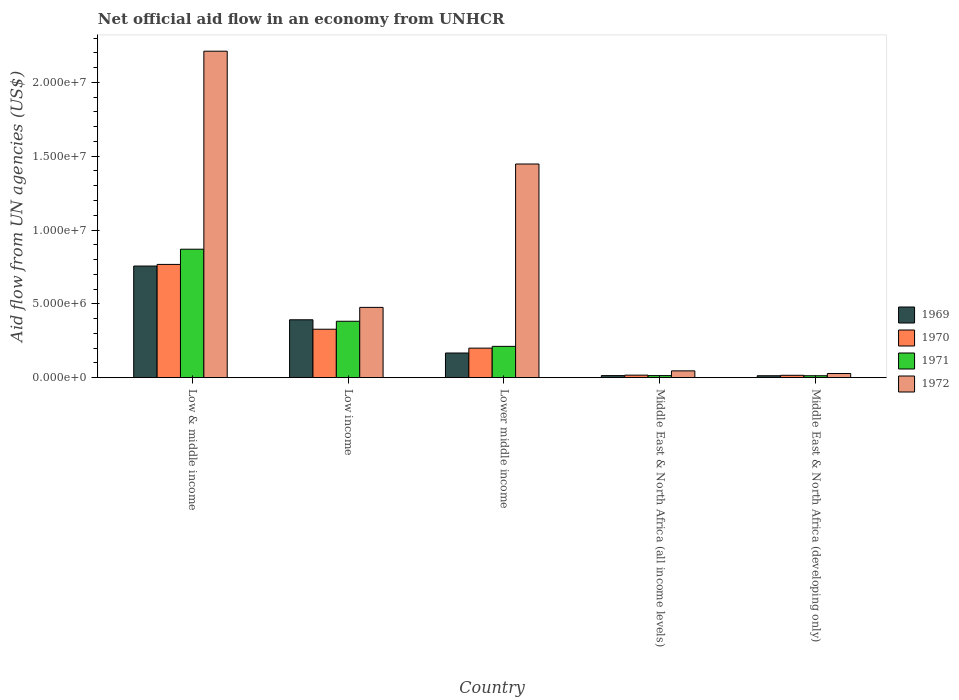How many groups of bars are there?
Provide a succinct answer. 5. What is the label of the 3rd group of bars from the left?
Your answer should be compact. Lower middle income. In how many cases, is the number of bars for a given country not equal to the number of legend labels?
Offer a terse response. 0. What is the net official aid flow in 1969 in Lower middle income?
Your response must be concise. 1.67e+06. Across all countries, what is the maximum net official aid flow in 1970?
Keep it short and to the point. 7.67e+06. Across all countries, what is the minimum net official aid flow in 1970?
Offer a terse response. 1.60e+05. In which country was the net official aid flow in 1969 maximum?
Your response must be concise. Low & middle income. In which country was the net official aid flow in 1971 minimum?
Offer a terse response. Middle East & North Africa (developing only). What is the total net official aid flow in 1969 in the graph?
Your answer should be very brief. 1.34e+07. What is the difference between the net official aid flow in 1971 in Low & middle income and that in Lower middle income?
Your answer should be very brief. 6.58e+06. What is the difference between the net official aid flow in 1972 in Low income and the net official aid flow in 1971 in Low & middle income?
Your answer should be compact. -3.94e+06. What is the average net official aid flow in 1971 per country?
Your response must be concise. 2.98e+06. What is the difference between the net official aid flow of/in 1969 and net official aid flow of/in 1971 in Low & middle income?
Provide a short and direct response. -1.14e+06. In how many countries, is the net official aid flow in 1971 greater than 3000000 US$?
Ensure brevity in your answer.  2. What is the difference between the highest and the second highest net official aid flow in 1971?
Give a very brief answer. 4.88e+06. What is the difference between the highest and the lowest net official aid flow in 1972?
Your answer should be very brief. 2.18e+07. In how many countries, is the net official aid flow in 1972 greater than the average net official aid flow in 1972 taken over all countries?
Keep it short and to the point. 2. How many bars are there?
Offer a terse response. 20. How many countries are there in the graph?
Your response must be concise. 5. Are the values on the major ticks of Y-axis written in scientific E-notation?
Make the answer very short. Yes. Does the graph contain any zero values?
Offer a terse response. No. Where does the legend appear in the graph?
Your response must be concise. Center right. How many legend labels are there?
Provide a succinct answer. 4. How are the legend labels stacked?
Offer a terse response. Vertical. What is the title of the graph?
Your response must be concise. Net official aid flow in an economy from UNHCR. Does "1971" appear as one of the legend labels in the graph?
Make the answer very short. Yes. What is the label or title of the X-axis?
Offer a terse response. Country. What is the label or title of the Y-axis?
Ensure brevity in your answer.  Aid flow from UN agencies (US$). What is the Aid flow from UN agencies (US$) in 1969 in Low & middle income?
Your answer should be very brief. 7.56e+06. What is the Aid flow from UN agencies (US$) of 1970 in Low & middle income?
Ensure brevity in your answer.  7.67e+06. What is the Aid flow from UN agencies (US$) of 1971 in Low & middle income?
Offer a very short reply. 8.70e+06. What is the Aid flow from UN agencies (US$) in 1972 in Low & middle income?
Make the answer very short. 2.21e+07. What is the Aid flow from UN agencies (US$) of 1969 in Low income?
Make the answer very short. 3.92e+06. What is the Aid flow from UN agencies (US$) in 1970 in Low income?
Your answer should be very brief. 3.28e+06. What is the Aid flow from UN agencies (US$) of 1971 in Low income?
Your response must be concise. 3.82e+06. What is the Aid flow from UN agencies (US$) in 1972 in Low income?
Your answer should be very brief. 4.76e+06. What is the Aid flow from UN agencies (US$) of 1969 in Lower middle income?
Offer a terse response. 1.67e+06. What is the Aid flow from UN agencies (US$) of 1971 in Lower middle income?
Your answer should be very brief. 2.12e+06. What is the Aid flow from UN agencies (US$) of 1972 in Lower middle income?
Give a very brief answer. 1.45e+07. What is the Aid flow from UN agencies (US$) of 1969 in Middle East & North Africa (all income levels)?
Your response must be concise. 1.40e+05. What is the Aid flow from UN agencies (US$) in 1969 in Middle East & North Africa (developing only)?
Your answer should be compact. 1.30e+05. What is the Aid flow from UN agencies (US$) in 1970 in Middle East & North Africa (developing only)?
Offer a terse response. 1.60e+05. What is the Aid flow from UN agencies (US$) in 1971 in Middle East & North Africa (developing only)?
Keep it short and to the point. 1.30e+05. Across all countries, what is the maximum Aid flow from UN agencies (US$) in 1969?
Keep it short and to the point. 7.56e+06. Across all countries, what is the maximum Aid flow from UN agencies (US$) in 1970?
Offer a terse response. 7.67e+06. Across all countries, what is the maximum Aid flow from UN agencies (US$) of 1971?
Your answer should be compact. 8.70e+06. Across all countries, what is the maximum Aid flow from UN agencies (US$) in 1972?
Ensure brevity in your answer.  2.21e+07. Across all countries, what is the minimum Aid flow from UN agencies (US$) of 1969?
Your answer should be very brief. 1.30e+05. Across all countries, what is the minimum Aid flow from UN agencies (US$) in 1971?
Your answer should be very brief. 1.30e+05. Across all countries, what is the minimum Aid flow from UN agencies (US$) of 1972?
Make the answer very short. 2.80e+05. What is the total Aid flow from UN agencies (US$) in 1969 in the graph?
Provide a short and direct response. 1.34e+07. What is the total Aid flow from UN agencies (US$) in 1970 in the graph?
Your answer should be very brief. 1.33e+07. What is the total Aid flow from UN agencies (US$) of 1971 in the graph?
Make the answer very short. 1.49e+07. What is the total Aid flow from UN agencies (US$) in 1972 in the graph?
Keep it short and to the point. 4.21e+07. What is the difference between the Aid flow from UN agencies (US$) in 1969 in Low & middle income and that in Low income?
Provide a succinct answer. 3.64e+06. What is the difference between the Aid flow from UN agencies (US$) of 1970 in Low & middle income and that in Low income?
Provide a short and direct response. 4.39e+06. What is the difference between the Aid flow from UN agencies (US$) of 1971 in Low & middle income and that in Low income?
Your response must be concise. 4.88e+06. What is the difference between the Aid flow from UN agencies (US$) in 1972 in Low & middle income and that in Low income?
Give a very brief answer. 1.74e+07. What is the difference between the Aid flow from UN agencies (US$) of 1969 in Low & middle income and that in Lower middle income?
Your answer should be compact. 5.89e+06. What is the difference between the Aid flow from UN agencies (US$) of 1970 in Low & middle income and that in Lower middle income?
Your response must be concise. 5.67e+06. What is the difference between the Aid flow from UN agencies (US$) of 1971 in Low & middle income and that in Lower middle income?
Your answer should be compact. 6.58e+06. What is the difference between the Aid flow from UN agencies (US$) in 1972 in Low & middle income and that in Lower middle income?
Ensure brevity in your answer.  7.64e+06. What is the difference between the Aid flow from UN agencies (US$) of 1969 in Low & middle income and that in Middle East & North Africa (all income levels)?
Provide a succinct answer. 7.42e+06. What is the difference between the Aid flow from UN agencies (US$) in 1970 in Low & middle income and that in Middle East & North Africa (all income levels)?
Provide a short and direct response. 7.50e+06. What is the difference between the Aid flow from UN agencies (US$) in 1971 in Low & middle income and that in Middle East & North Africa (all income levels)?
Your response must be concise. 8.56e+06. What is the difference between the Aid flow from UN agencies (US$) of 1972 in Low & middle income and that in Middle East & North Africa (all income levels)?
Make the answer very short. 2.16e+07. What is the difference between the Aid flow from UN agencies (US$) in 1969 in Low & middle income and that in Middle East & North Africa (developing only)?
Offer a terse response. 7.43e+06. What is the difference between the Aid flow from UN agencies (US$) of 1970 in Low & middle income and that in Middle East & North Africa (developing only)?
Give a very brief answer. 7.51e+06. What is the difference between the Aid flow from UN agencies (US$) of 1971 in Low & middle income and that in Middle East & North Africa (developing only)?
Your answer should be very brief. 8.57e+06. What is the difference between the Aid flow from UN agencies (US$) of 1972 in Low & middle income and that in Middle East & North Africa (developing only)?
Give a very brief answer. 2.18e+07. What is the difference between the Aid flow from UN agencies (US$) in 1969 in Low income and that in Lower middle income?
Make the answer very short. 2.25e+06. What is the difference between the Aid flow from UN agencies (US$) in 1970 in Low income and that in Lower middle income?
Keep it short and to the point. 1.28e+06. What is the difference between the Aid flow from UN agencies (US$) in 1971 in Low income and that in Lower middle income?
Provide a succinct answer. 1.70e+06. What is the difference between the Aid flow from UN agencies (US$) of 1972 in Low income and that in Lower middle income?
Give a very brief answer. -9.71e+06. What is the difference between the Aid flow from UN agencies (US$) of 1969 in Low income and that in Middle East & North Africa (all income levels)?
Your answer should be compact. 3.78e+06. What is the difference between the Aid flow from UN agencies (US$) of 1970 in Low income and that in Middle East & North Africa (all income levels)?
Give a very brief answer. 3.11e+06. What is the difference between the Aid flow from UN agencies (US$) in 1971 in Low income and that in Middle East & North Africa (all income levels)?
Your answer should be very brief. 3.68e+06. What is the difference between the Aid flow from UN agencies (US$) in 1972 in Low income and that in Middle East & North Africa (all income levels)?
Your answer should be very brief. 4.30e+06. What is the difference between the Aid flow from UN agencies (US$) in 1969 in Low income and that in Middle East & North Africa (developing only)?
Ensure brevity in your answer.  3.79e+06. What is the difference between the Aid flow from UN agencies (US$) of 1970 in Low income and that in Middle East & North Africa (developing only)?
Offer a very short reply. 3.12e+06. What is the difference between the Aid flow from UN agencies (US$) in 1971 in Low income and that in Middle East & North Africa (developing only)?
Your response must be concise. 3.69e+06. What is the difference between the Aid flow from UN agencies (US$) in 1972 in Low income and that in Middle East & North Africa (developing only)?
Keep it short and to the point. 4.48e+06. What is the difference between the Aid flow from UN agencies (US$) of 1969 in Lower middle income and that in Middle East & North Africa (all income levels)?
Offer a very short reply. 1.53e+06. What is the difference between the Aid flow from UN agencies (US$) of 1970 in Lower middle income and that in Middle East & North Africa (all income levels)?
Give a very brief answer. 1.83e+06. What is the difference between the Aid flow from UN agencies (US$) of 1971 in Lower middle income and that in Middle East & North Africa (all income levels)?
Your answer should be compact. 1.98e+06. What is the difference between the Aid flow from UN agencies (US$) in 1972 in Lower middle income and that in Middle East & North Africa (all income levels)?
Keep it short and to the point. 1.40e+07. What is the difference between the Aid flow from UN agencies (US$) of 1969 in Lower middle income and that in Middle East & North Africa (developing only)?
Your answer should be very brief. 1.54e+06. What is the difference between the Aid flow from UN agencies (US$) of 1970 in Lower middle income and that in Middle East & North Africa (developing only)?
Your response must be concise. 1.84e+06. What is the difference between the Aid flow from UN agencies (US$) in 1971 in Lower middle income and that in Middle East & North Africa (developing only)?
Offer a terse response. 1.99e+06. What is the difference between the Aid flow from UN agencies (US$) in 1972 in Lower middle income and that in Middle East & North Africa (developing only)?
Offer a terse response. 1.42e+07. What is the difference between the Aid flow from UN agencies (US$) of 1969 in Middle East & North Africa (all income levels) and that in Middle East & North Africa (developing only)?
Your response must be concise. 10000. What is the difference between the Aid flow from UN agencies (US$) of 1970 in Middle East & North Africa (all income levels) and that in Middle East & North Africa (developing only)?
Provide a succinct answer. 10000. What is the difference between the Aid flow from UN agencies (US$) of 1971 in Middle East & North Africa (all income levels) and that in Middle East & North Africa (developing only)?
Ensure brevity in your answer.  10000. What is the difference between the Aid flow from UN agencies (US$) of 1972 in Middle East & North Africa (all income levels) and that in Middle East & North Africa (developing only)?
Give a very brief answer. 1.80e+05. What is the difference between the Aid flow from UN agencies (US$) of 1969 in Low & middle income and the Aid flow from UN agencies (US$) of 1970 in Low income?
Keep it short and to the point. 4.28e+06. What is the difference between the Aid flow from UN agencies (US$) of 1969 in Low & middle income and the Aid flow from UN agencies (US$) of 1971 in Low income?
Give a very brief answer. 3.74e+06. What is the difference between the Aid flow from UN agencies (US$) of 1969 in Low & middle income and the Aid flow from UN agencies (US$) of 1972 in Low income?
Give a very brief answer. 2.80e+06. What is the difference between the Aid flow from UN agencies (US$) of 1970 in Low & middle income and the Aid flow from UN agencies (US$) of 1971 in Low income?
Provide a succinct answer. 3.85e+06. What is the difference between the Aid flow from UN agencies (US$) in 1970 in Low & middle income and the Aid flow from UN agencies (US$) in 1972 in Low income?
Offer a terse response. 2.91e+06. What is the difference between the Aid flow from UN agencies (US$) in 1971 in Low & middle income and the Aid flow from UN agencies (US$) in 1972 in Low income?
Make the answer very short. 3.94e+06. What is the difference between the Aid flow from UN agencies (US$) of 1969 in Low & middle income and the Aid flow from UN agencies (US$) of 1970 in Lower middle income?
Offer a terse response. 5.56e+06. What is the difference between the Aid flow from UN agencies (US$) in 1969 in Low & middle income and the Aid flow from UN agencies (US$) in 1971 in Lower middle income?
Make the answer very short. 5.44e+06. What is the difference between the Aid flow from UN agencies (US$) in 1969 in Low & middle income and the Aid flow from UN agencies (US$) in 1972 in Lower middle income?
Your answer should be very brief. -6.91e+06. What is the difference between the Aid flow from UN agencies (US$) of 1970 in Low & middle income and the Aid flow from UN agencies (US$) of 1971 in Lower middle income?
Ensure brevity in your answer.  5.55e+06. What is the difference between the Aid flow from UN agencies (US$) of 1970 in Low & middle income and the Aid flow from UN agencies (US$) of 1972 in Lower middle income?
Keep it short and to the point. -6.80e+06. What is the difference between the Aid flow from UN agencies (US$) of 1971 in Low & middle income and the Aid flow from UN agencies (US$) of 1972 in Lower middle income?
Your response must be concise. -5.77e+06. What is the difference between the Aid flow from UN agencies (US$) in 1969 in Low & middle income and the Aid flow from UN agencies (US$) in 1970 in Middle East & North Africa (all income levels)?
Ensure brevity in your answer.  7.39e+06. What is the difference between the Aid flow from UN agencies (US$) in 1969 in Low & middle income and the Aid flow from UN agencies (US$) in 1971 in Middle East & North Africa (all income levels)?
Your response must be concise. 7.42e+06. What is the difference between the Aid flow from UN agencies (US$) of 1969 in Low & middle income and the Aid flow from UN agencies (US$) of 1972 in Middle East & North Africa (all income levels)?
Provide a short and direct response. 7.10e+06. What is the difference between the Aid flow from UN agencies (US$) in 1970 in Low & middle income and the Aid flow from UN agencies (US$) in 1971 in Middle East & North Africa (all income levels)?
Ensure brevity in your answer.  7.53e+06. What is the difference between the Aid flow from UN agencies (US$) in 1970 in Low & middle income and the Aid flow from UN agencies (US$) in 1972 in Middle East & North Africa (all income levels)?
Offer a terse response. 7.21e+06. What is the difference between the Aid flow from UN agencies (US$) of 1971 in Low & middle income and the Aid flow from UN agencies (US$) of 1972 in Middle East & North Africa (all income levels)?
Ensure brevity in your answer.  8.24e+06. What is the difference between the Aid flow from UN agencies (US$) of 1969 in Low & middle income and the Aid flow from UN agencies (US$) of 1970 in Middle East & North Africa (developing only)?
Make the answer very short. 7.40e+06. What is the difference between the Aid flow from UN agencies (US$) in 1969 in Low & middle income and the Aid flow from UN agencies (US$) in 1971 in Middle East & North Africa (developing only)?
Your answer should be very brief. 7.43e+06. What is the difference between the Aid flow from UN agencies (US$) of 1969 in Low & middle income and the Aid flow from UN agencies (US$) of 1972 in Middle East & North Africa (developing only)?
Your response must be concise. 7.28e+06. What is the difference between the Aid flow from UN agencies (US$) of 1970 in Low & middle income and the Aid flow from UN agencies (US$) of 1971 in Middle East & North Africa (developing only)?
Make the answer very short. 7.54e+06. What is the difference between the Aid flow from UN agencies (US$) in 1970 in Low & middle income and the Aid flow from UN agencies (US$) in 1972 in Middle East & North Africa (developing only)?
Your answer should be very brief. 7.39e+06. What is the difference between the Aid flow from UN agencies (US$) in 1971 in Low & middle income and the Aid flow from UN agencies (US$) in 1972 in Middle East & North Africa (developing only)?
Offer a very short reply. 8.42e+06. What is the difference between the Aid flow from UN agencies (US$) in 1969 in Low income and the Aid flow from UN agencies (US$) in 1970 in Lower middle income?
Make the answer very short. 1.92e+06. What is the difference between the Aid flow from UN agencies (US$) in 1969 in Low income and the Aid flow from UN agencies (US$) in 1971 in Lower middle income?
Keep it short and to the point. 1.80e+06. What is the difference between the Aid flow from UN agencies (US$) in 1969 in Low income and the Aid flow from UN agencies (US$) in 1972 in Lower middle income?
Keep it short and to the point. -1.06e+07. What is the difference between the Aid flow from UN agencies (US$) in 1970 in Low income and the Aid flow from UN agencies (US$) in 1971 in Lower middle income?
Give a very brief answer. 1.16e+06. What is the difference between the Aid flow from UN agencies (US$) of 1970 in Low income and the Aid flow from UN agencies (US$) of 1972 in Lower middle income?
Give a very brief answer. -1.12e+07. What is the difference between the Aid flow from UN agencies (US$) of 1971 in Low income and the Aid flow from UN agencies (US$) of 1972 in Lower middle income?
Your response must be concise. -1.06e+07. What is the difference between the Aid flow from UN agencies (US$) in 1969 in Low income and the Aid flow from UN agencies (US$) in 1970 in Middle East & North Africa (all income levels)?
Provide a short and direct response. 3.75e+06. What is the difference between the Aid flow from UN agencies (US$) in 1969 in Low income and the Aid flow from UN agencies (US$) in 1971 in Middle East & North Africa (all income levels)?
Your response must be concise. 3.78e+06. What is the difference between the Aid flow from UN agencies (US$) in 1969 in Low income and the Aid flow from UN agencies (US$) in 1972 in Middle East & North Africa (all income levels)?
Your answer should be very brief. 3.46e+06. What is the difference between the Aid flow from UN agencies (US$) in 1970 in Low income and the Aid flow from UN agencies (US$) in 1971 in Middle East & North Africa (all income levels)?
Your answer should be compact. 3.14e+06. What is the difference between the Aid flow from UN agencies (US$) of 1970 in Low income and the Aid flow from UN agencies (US$) of 1972 in Middle East & North Africa (all income levels)?
Give a very brief answer. 2.82e+06. What is the difference between the Aid flow from UN agencies (US$) in 1971 in Low income and the Aid flow from UN agencies (US$) in 1972 in Middle East & North Africa (all income levels)?
Offer a very short reply. 3.36e+06. What is the difference between the Aid flow from UN agencies (US$) of 1969 in Low income and the Aid flow from UN agencies (US$) of 1970 in Middle East & North Africa (developing only)?
Give a very brief answer. 3.76e+06. What is the difference between the Aid flow from UN agencies (US$) in 1969 in Low income and the Aid flow from UN agencies (US$) in 1971 in Middle East & North Africa (developing only)?
Ensure brevity in your answer.  3.79e+06. What is the difference between the Aid flow from UN agencies (US$) in 1969 in Low income and the Aid flow from UN agencies (US$) in 1972 in Middle East & North Africa (developing only)?
Your answer should be very brief. 3.64e+06. What is the difference between the Aid flow from UN agencies (US$) in 1970 in Low income and the Aid flow from UN agencies (US$) in 1971 in Middle East & North Africa (developing only)?
Provide a succinct answer. 3.15e+06. What is the difference between the Aid flow from UN agencies (US$) in 1971 in Low income and the Aid flow from UN agencies (US$) in 1972 in Middle East & North Africa (developing only)?
Your response must be concise. 3.54e+06. What is the difference between the Aid flow from UN agencies (US$) of 1969 in Lower middle income and the Aid flow from UN agencies (US$) of 1970 in Middle East & North Africa (all income levels)?
Your answer should be very brief. 1.50e+06. What is the difference between the Aid flow from UN agencies (US$) of 1969 in Lower middle income and the Aid flow from UN agencies (US$) of 1971 in Middle East & North Africa (all income levels)?
Provide a short and direct response. 1.53e+06. What is the difference between the Aid flow from UN agencies (US$) of 1969 in Lower middle income and the Aid flow from UN agencies (US$) of 1972 in Middle East & North Africa (all income levels)?
Your answer should be very brief. 1.21e+06. What is the difference between the Aid flow from UN agencies (US$) in 1970 in Lower middle income and the Aid flow from UN agencies (US$) in 1971 in Middle East & North Africa (all income levels)?
Keep it short and to the point. 1.86e+06. What is the difference between the Aid flow from UN agencies (US$) of 1970 in Lower middle income and the Aid flow from UN agencies (US$) of 1972 in Middle East & North Africa (all income levels)?
Your response must be concise. 1.54e+06. What is the difference between the Aid flow from UN agencies (US$) of 1971 in Lower middle income and the Aid flow from UN agencies (US$) of 1972 in Middle East & North Africa (all income levels)?
Keep it short and to the point. 1.66e+06. What is the difference between the Aid flow from UN agencies (US$) in 1969 in Lower middle income and the Aid flow from UN agencies (US$) in 1970 in Middle East & North Africa (developing only)?
Offer a very short reply. 1.51e+06. What is the difference between the Aid flow from UN agencies (US$) in 1969 in Lower middle income and the Aid flow from UN agencies (US$) in 1971 in Middle East & North Africa (developing only)?
Give a very brief answer. 1.54e+06. What is the difference between the Aid flow from UN agencies (US$) in 1969 in Lower middle income and the Aid flow from UN agencies (US$) in 1972 in Middle East & North Africa (developing only)?
Keep it short and to the point. 1.39e+06. What is the difference between the Aid flow from UN agencies (US$) of 1970 in Lower middle income and the Aid flow from UN agencies (US$) of 1971 in Middle East & North Africa (developing only)?
Keep it short and to the point. 1.87e+06. What is the difference between the Aid flow from UN agencies (US$) of 1970 in Lower middle income and the Aid flow from UN agencies (US$) of 1972 in Middle East & North Africa (developing only)?
Provide a short and direct response. 1.72e+06. What is the difference between the Aid flow from UN agencies (US$) in 1971 in Lower middle income and the Aid flow from UN agencies (US$) in 1972 in Middle East & North Africa (developing only)?
Offer a very short reply. 1.84e+06. What is the difference between the Aid flow from UN agencies (US$) in 1969 in Middle East & North Africa (all income levels) and the Aid flow from UN agencies (US$) in 1970 in Middle East & North Africa (developing only)?
Your answer should be compact. -2.00e+04. What is the difference between the Aid flow from UN agencies (US$) of 1969 in Middle East & North Africa (all income levels) and the Aid flow from UN agencies (US$) of 1972 in Middle East & North Africa (developing only)?
Offer a very short reply. -1.40e+05. What is the difference between the Aid flow from UN agencies (US$) in 1970 in Middle East & North Africa (all income levels) and the Aid flow from UN agencies (US$) in 1972 in Middle East & North Africa (developing only)?
Make the answer very short. -1.10e+05. What is the difference between the Aid flow from UN agencies (US$) in 1971 in Middle East & North Africa (all income levels) and the Aid flow from UN agencies (US$) in 1972 in Middle East & North Africa (developing only)?
Give a very brief answer. -1.40e+05. What is the average Aid flow from UN agencies (US$) in 1969 per country?
Offer a terse response. 2.68e+06. What is the average Aid flow from UN agencies (US$) of 1970 per country?
Your response must be concise. 2.66e+06. What is the average Aid flow from UN agencies (US$) of 1971 per country?
Make the answer very short. 2.98e+06. What is the average Aid flow from UN agencies (US$) in 1972 per country?
Give a very brief answer. 8.42e+06. What is the difference between the Aid flow from UN agencies (US$) in 1969 and Aid flow from UN agencies (US$) in 1971 in Low & middle income?
Offer a very short reply. -1.14e+06. What is the difference between the Aid flow from UN agencies (US$) in 1969 and Aid flow from UN agencies (US$) in 1972 in Low & middle income?
Ensure brevity in your answer.  -1.46e+07. What is the difference between the Aid flow from UN agencies (US$) in 1970 and Aid flow from UN agencies (US$) in 1971 in Low & middle income?
Ensure brevity in your answer.  -1.03e+06. What is the difference between the Aid flow from UN agencies (US$) of 1970 and Aid flow from UN agencies (US$) of 1972 in Low & middle income?
Your answer should be very brief. -1.44e+07. What is the difference between the Aid flow from UN agencies (US$) in 1971 and Aid flow from UN agencies (US$) in 1972 in Low & middle income?
Keep it short and to the point. -1.34e+07. What is the difference between the Aid flow from UN agencies (US$) of 1969 and Aid flow from UN agencies (US$) of 1970 in Low income?
Provide a succinct answer. 6.40e+05. What is the difference between the Aid flow from UN agencies (US$) in 1969 and Aid flow from UN agencies (US$) in 1971 in Low income?
Provide a succinct answer. 1.00e+05. What is the difference between the Aid flow from UN agencies (US$) in 1969 and Aid flow from UN agencies (US$) in 1972 in Low income?
Provide a succinct answer. -8.40e+05. What is the difference between the Aid flow from UN agencies (US$) of 1970 and Aid flow from UN agencies (US$) of 1971 in Low income?
Your response must be concise. -5.40e+05. What is the difference between the Aid flow from UN agencies (US$) in 1970 and Aid flow from UN agencies (US$) in 1972 in Low income?
Offer a very short reply. -1.48e+06. What is the difference between the Aid flow from UN agencies (US$) in 1971 and Aid flow from UN agencies (US$) in 1972 in Low income?
Provide a short and direct response. -9.40e+05. What is the difference between the Aid flow from UN agencies (US$) in 1969 and Aid flow from UN agencies (US$) in 1970 in Lower middle income?
Ensure brevity in your answer.  -3.30e+05. What is the difference between the Aid flow from UN agencies (US$) of 1969 and Aid flow from UN agencies (US$) of 1971 in Lower middle income?
Give a very brief answer. -4.50e+05. What is the difference between the Aid flow from UN agencies (US$) of 1969 and Aid flow from UN agencies (US$) of 1972 in Lower middle income?
Offer a very short reply. -1.28e+07. What is the difference between the Aid flow from UN agencies (US$) of 1970 and Aid flow from UN agencies (US$) of 1971 in Lower middle income?
Ensure brevity in your answer.  -1.20e+05. What is the difference between the Aid flow from UN agencies (US$) in 1970 and Aid flow from UN agencies (US$) in 1972 in Lower middle income?
Offer a very short reply. -1.25e+07. What is the difference between the Aid flow from UN agencies (US$) in 1971 and Aid flow from UN agencies (US$) in 1972 in Lower middle income?
Give a very brief answer. -1.24e+07. What is the difference between the Aid flow from UN agencies (US$) of 1969 and Aid flow from UN agencies (US$) of 1971 in Middle East & North Africa (all income levels)?
Keep it short and to the point. 0. What is the difference between the Aid flow from UN agencies (US$) in 1969 and Aid flow from UN agencies (US$) in 1972 in Middle East & North Africa (all income levels)?
Provide a succinct answer. -3.20e+05. What is the difference between the Aid flow from UN agencies (US$) in 1970 and Aid flow from UN agencies (US$) in 1972 in Middle East & North Africa (all income levels)?
Your response must be concise. -2.90e+05. What is the difference between the Aid flow from UN agencies (US$) of 1971 and Aid flow from UN agencies (US$) of 1972 in Middle East & North Africa (all income levels)?
Your answer should be very brief. -3.20e+05. What is the difference between the Aid flow from UN agencies (US$) in 1970 and Aid flow from UN agencies (US$) in 1971 in Middle East & North Africa (developing only)?
Offer a very short reply. 3.00e+04. What is the difference between the Aid flow from UN agencies (US$) in 1970 and Aid flow from UN agencies (US$) in 1972 in Middle East & North Africa (developing only)?
Your response must be concise. -1.20e+05. What is the ratio of the Aid flow from UN agencies (US$) of 1969 in Low & middle income to that in Low income?
Make the answer very short. 1.93. What is the ratio of the Aid flow from UN agencies (US$) in 1970 in Low & middle income to that in Low income?
Offer a terse response. 2.34. What is the ratio of the Aid flow from UN agencies (US$) of 1971 in Low & middle income to that in Low income?
Your answer should be compact. 2.28. What is the ratio of the Aid flow from UN agencies (US$) of 1972 in Low & middle income to that in Low income?
Provide a short and direct response. 4.64. What is the ratio of the Aid flow from UN agencies (US$) in 1969 in Low & middle income to that in Lower middle income?
Make the answer very short. 4.53. What is the ratio of the Aid flow from UN agencies (US$) of 1970 in Low & middle income to that in Lower middle income?
Offer a terse response. 3.83. What is the ratio of the Aid flow from UN agencies (US$) of 1971 in Low & middle income to that in Lower middle income?
Your response must be concise. 4.1. What is the ratio of the Aid flow from UN agencies (US$) in 1972 in Low & middle income to that in Lower middle income?
Provide a succinct answer. 1.53. What is the ratio of the Aid flow from UN agencies (US$) of 1969 in Low & middle income to that in Middle East & North Africa (all income levels)?
Offer a terse response. 54. What is the ratio of the Aid flow from UN agencies (US$) of 1970 in Low & middle income to that in Middle East & North Africa (all income levels)?
Give a very brief answer. 45.12. What is the ratio of the Aid flow from UN agencies (US$) of 1971 in Low & middle income to that in Middle East & North Africa (all income levels)?
Your answer should be very brief. 62.14. What is the ratio of the Aid flow from UN agencies (US$) of 1972 in Low & middle income to that in Middle East & North Africa (all income levels)?
Your answer should be very brief. 48.07. What is the ratio of the Aid flow from UN agencies (US$) of 1969 in Low & middle income to that in Middle East & North Africa (developing only)?
Ensure brevity in your answer.  58.15. What is the ratio of the Aid flow from UN agencies (US$) of 1970 in Low & middle income to that in Middle East & North Africa (developing only)?
Your answer should be very brief. 47.94. What is the ratio of the Aid flow from UN agencies (US$) in 1971 in Low & middle income to that in Middle East & North Africa (developing only)?
Your response must be concise. 66.92. What is the ratio of the Aid flow from UN agencies (US$) in 1972 in Low & middle income to that in Middle East & North Africa (developing only)?
Offer a very short reply. 78.96. What is the ratio of the Aid flow from UN agencies (US$) of 1969 in Low income to that in Lower middle income?
Keep it short and to the point. 2.35. What is the ratio of the Aid flow from UN agencies (US$) of 1970 in Low income to that in Lower middle income?
Your response must be concise. 1.64. What is the ratio of the Aid flow from UN agencies (US$) in 1971 in Low income to that in Lower middle income?
Your response must be concise. 1.8. What is the ratio of the Aid flow from UN agencies (US$) in 1972 in Low income to that in Lower middle income?
Provide a short and direct response. 0.33. What is the ratio of the Aid flow from UN agencies (US$) of 1969 in Low income to that in Middle East & North Africa (all income levels)?
Give a very brief answer. 28. What is the ratio of the Aid flow from UN agencies (US$) in 1970 in Low income to that in Middle East & North Africa (all income levels)?
Give a very brief answer. 19.29. What is the ratio of the Aid flow from UN agencies (US$) in 1971 in Low income to that in Middle East & North Africa (all income levels)?
Offer a terse response. 27.29. What is the ratio of the Aid flow from UN agencies (US$) of 1972 in Low income to that in Middle East & North Africa (all income levels)?
Make the answer very short. 10.35. What is the ratio of the Aid flow from UN agencies (US$) of 1969 in Low income to that in Middle East & North Africa (developing only)?
Make the answer very short. 30.15. What is the ratio of the Aid flow from UN agencies (US$) in 1971 in Low income to that in Middle East & North Africa (developing only)?
Your answer should be very brief. 29.38. What is the ratio of the Aid flow from UN agencies (US$) in 1969 in Lower middle income to that in Middle East & North Africa (all income levels)?
Keep it short and to the point. 11.93. What is the ratio of the Aid flow from UN agencies (US$) in 1970 in Lower middle income to that in Middle East & North Africa (all income levels)?
Give a very brief answer. 11.76. What is the ratio of the Aid flow from UN agencies (US$) of 1971 in Lower middle income to that in Middle East & North Africa (all income levels)?
Give a very brief answer. 15.14. What is the ratio of the Aid flow from UN agencies (US$) in 1972 in Lower middle income to that in Middle East & North Africa (all income levels)?
Provide a short and direct response. 31.46. What is the ratio of the Aid flow from UN agencies (US$) of 1969 in Lower middle income to that in Middle East & North Africa (developing only)?
Provide a succinct answer. 12.85. What is the ratio of the Aid flow from UN agencies (US$) of 1970 in Lower middle income to that in Middle East & North Africa (developing only)?
Provide a short and direct response. 12.5. What is the ratio of the Aid flow from UN agencies (US$) in 1971 in Lower middle income to that in Middle East & North Africa (developing only)?
Your answer should be very brief. 16.31. What is the ratio of the Aid flow from UN agencies (US$) in 1972 in Lower middle income to that in Middle East & North Africa (developing only)?
Your answer should be very brief. 51.68. What is the ratio of the Aid flow from UN agencies (US$) in 1969 in Middle East & North Africa (all income levels) to that in Middle East & North Africa (developing only)?
Provide a short and direct response. 1.08. What is the ratio of the Aid flow from UN agencies (US$) in 1971 in Middle East & North Africa (all income levels) to that in Middle East & North Africa (developing only)?
Make the answer very short. 1.08. What is the ratio of the Aid flow from UN agencies (US$) of 1972 in Middle East & North Africa (all income levels) to that in Middle East & North Africa (developing only)?
Provide a succinct answer. 1.64. What is the difference between the highest and the second highest Aid flow from UN agencies (US$) in 1969?
Offer a very short reply. 3.64e+06. What is the difference between the highest and the second highest Aid flow from UN agencies (US$) of 1970?
Offer a terse response. 4.39e+06. What is the difference between the highest and the second highest Aid flow from UN agencies (US$) in 1971?
Make the answer very short. 4.88e+06. What is the difference between the highest and the second highest Aid flow from UN agencies (US$) of 1972?
Offer a terse response. 7.64e+06. What is the difference between the highest and the lowest Aid flow from UN agencies (US$) of 1969?
Offer a very short reply. 7.43e+06. What is the difference between the highest and the lowest Aid flow from UN agencies (US$) of 1970?
Your response must be concise. 7.51e+06. What is the difference between the highest and the lowest Aid flow from UN agencies (US$) in 1971?
Your answer should be compact. 8.57e+06. What is the difference between the highest and the lowest Aid flow from UN agencies (US$) of 1972?
Provide a succinct answer. 2.18e+07. 